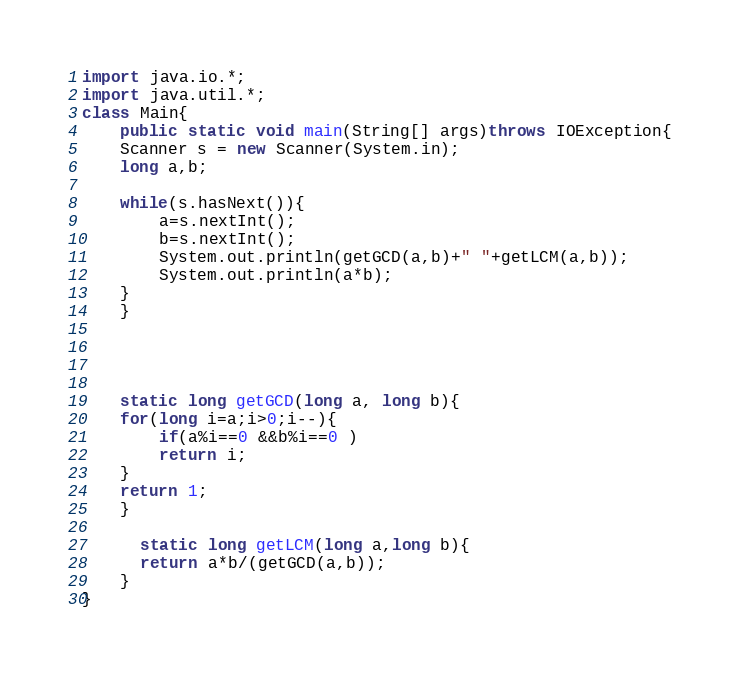Convert code to text. <code><loc_0><loc_0><loc_500><loc_500><_Java_>import java.io.*;
import java.util.*;
class Main{
    public static void main(String[] args)throws IOException{
	Scanner s = new Scanner(System.in);
	long a,b;
	
	while(s.hasNext()){
	    a=s.nextInt();
	    b=s.nextInt();
	    System.out.println(getGCD(a,b)+" "+getLCM(a,b));
	    System.out.println(a*b);
	}
    }
    
    
  
    
    static long getGCD(long a, long b){
	for(long i=a;i>0;i--){
	    if(a%i==0 &&b%i==0 )
		return i;
	}
	return 1;
    }

      static long getLCM(long a,long b){
	  return a*b/(getGCD(a,b));
    }
}</code> 